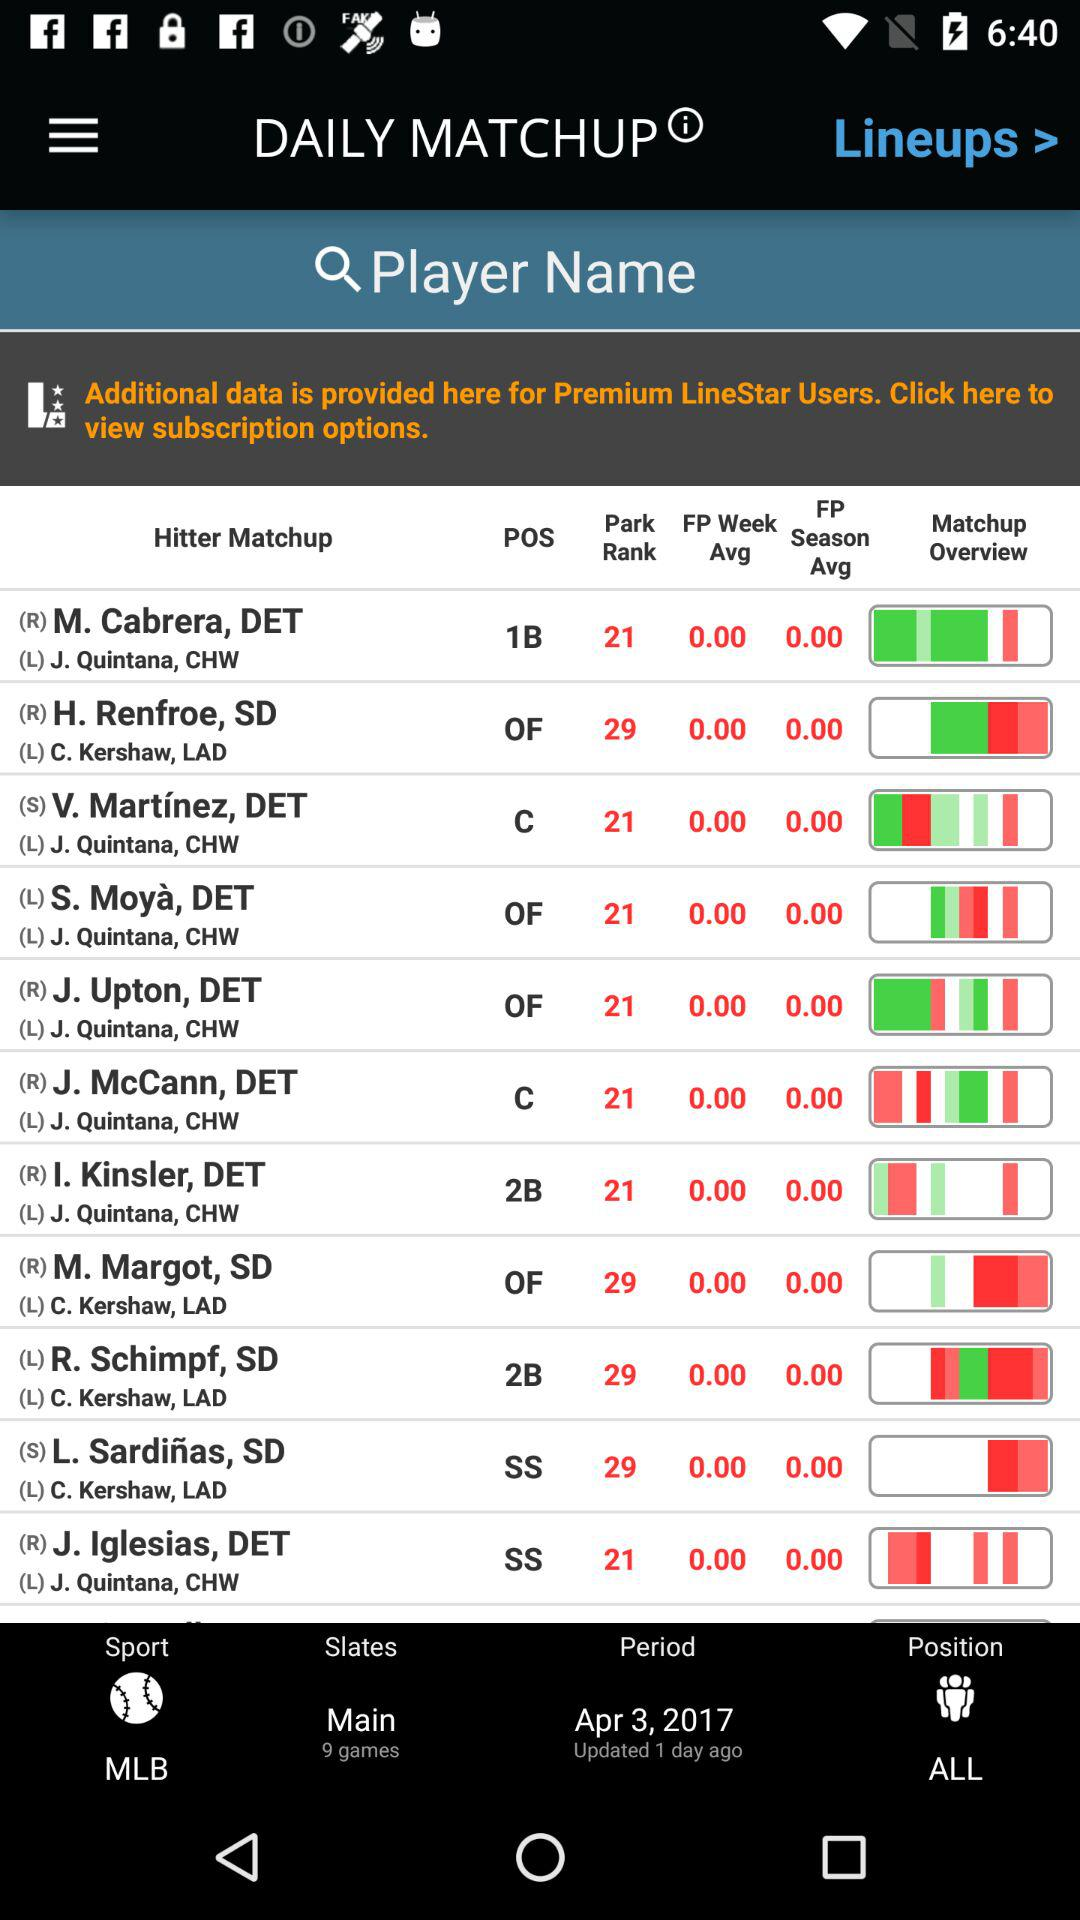When was the period date updated? The period date was updated 1 day ago. 